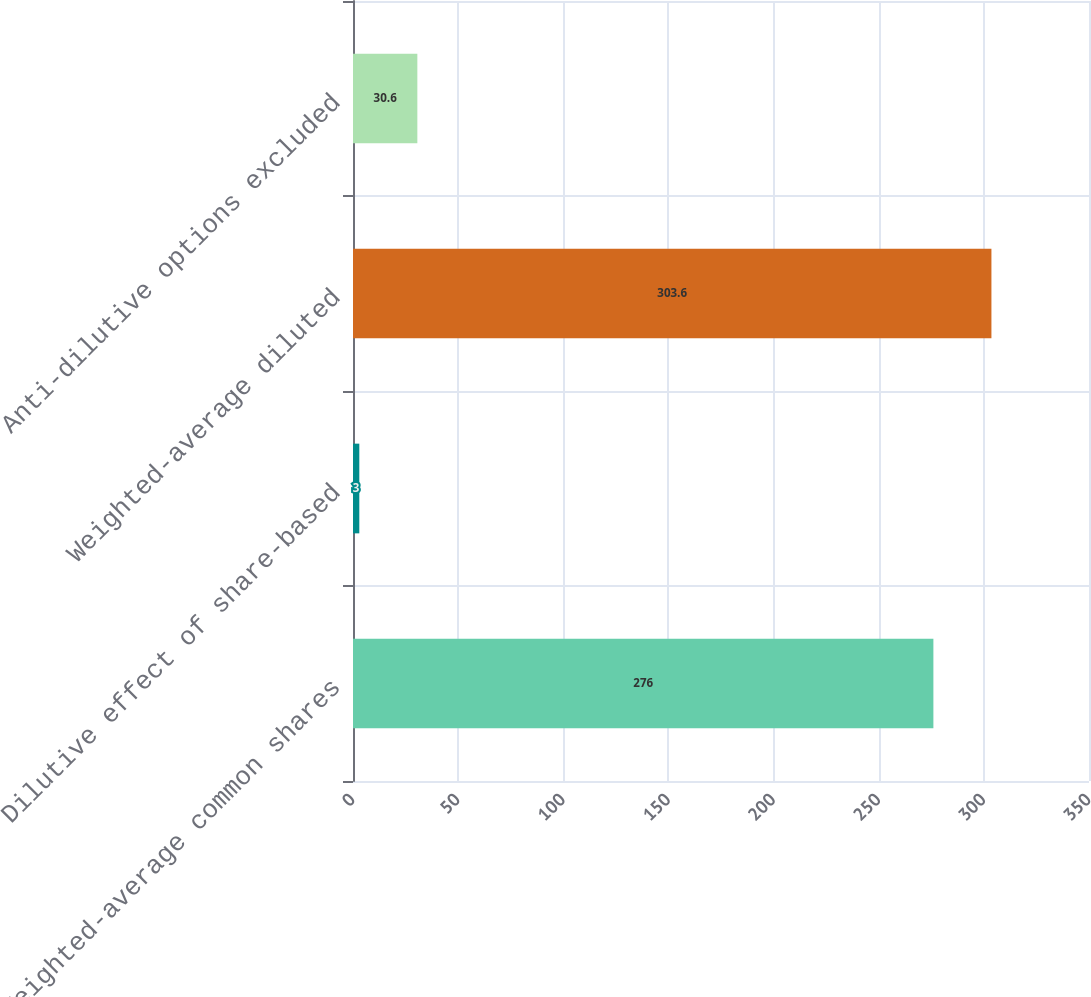<chart> <loc_0><loc_0><loc_500><loc_500><bar_chart><fcel>Weighted-average common shares<fcel>Dilutive effect of share-based<fcel>Weighted-average diluted<fcel>Anti-dilutive options excluded<nl><fcel>276<fcel>3<fcel>303.6<fcel>30.6<nl></chart> 